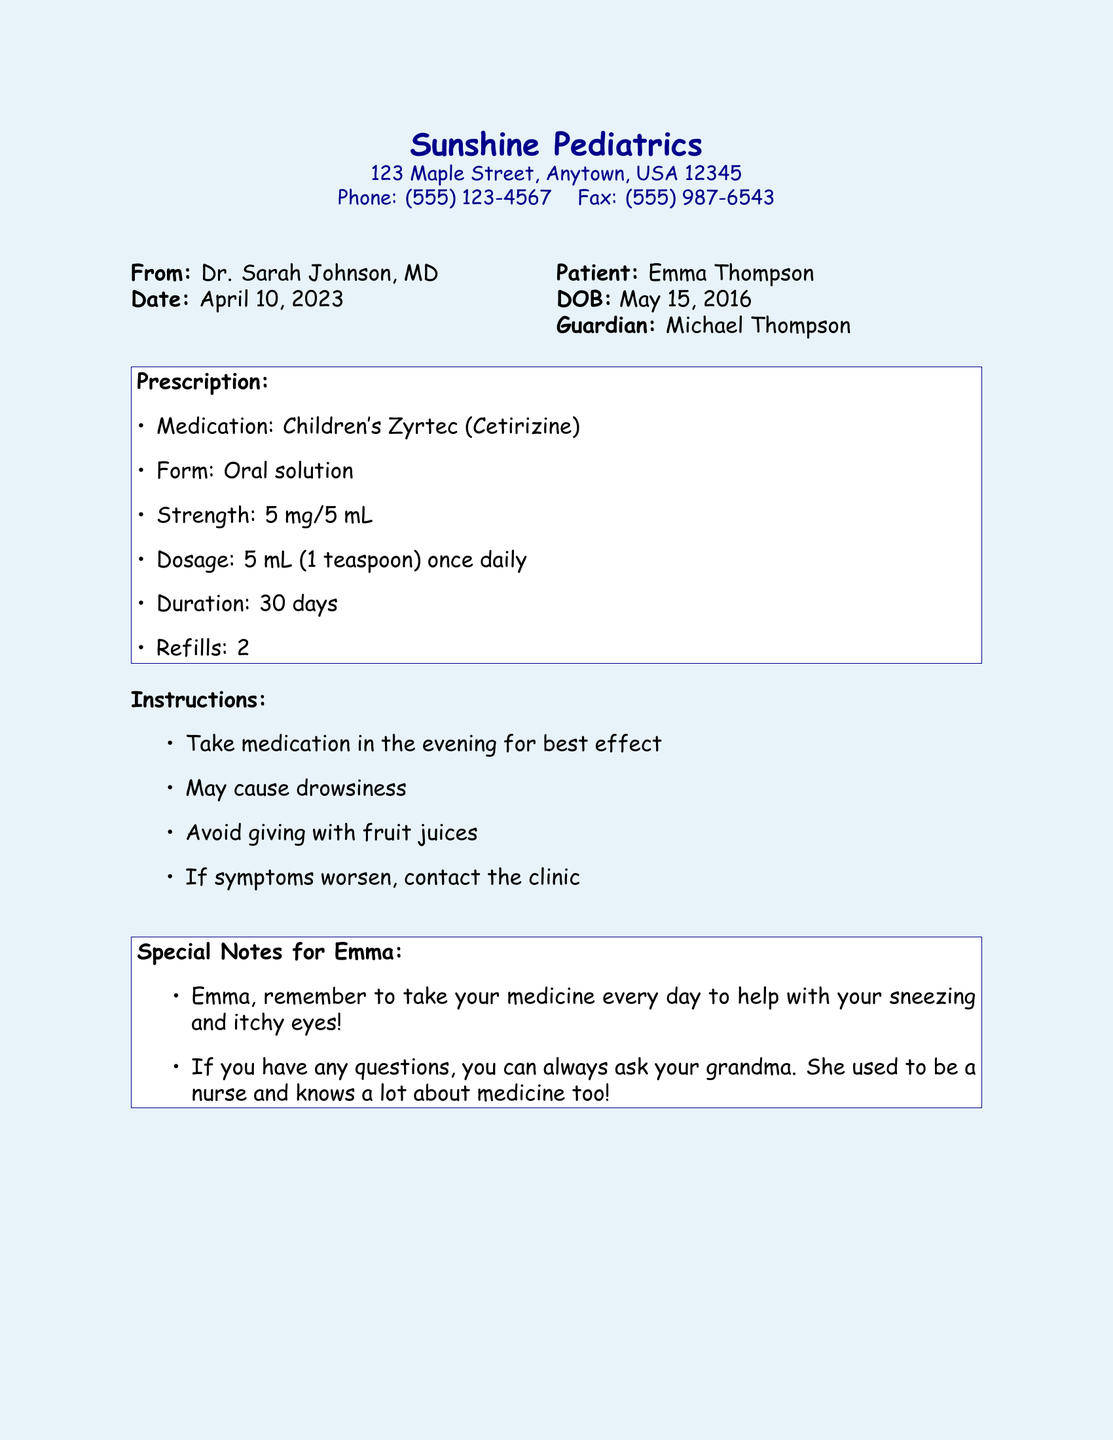What is the name of the patient? The patient's name is mentioned in the document as Emma Thompson.
Answer: Emma Thompson What is the name of the medication prescribed? The document specifies the medication as Children's Zyrtec.
Answer: Children's Zyrtec What is the dosage form of the medication? The document states the dosage form of the medication is an oral solution.
Answer: Oral solution How long should the medication be taken? The duration for taking the medication is specified as 30 days in the document.
Answer: 30 days When should the medication be taken? The document recommends taking the medication in the evening for best effect.
Answer: Evening What is the strength of the medication? The strength of the medication is noted as 5 mg/5 mL in the document.
Answer: 5 mg/5 mL How many refills are allowed? The number of refills mentioned in the document is 2.
Answer: 2 Who is the prescribing doctor? The doctor's name is provided in the document as Dr. Sarah Johnson.
Answer: Dr. Sarah Johnson What should be avoided when taking the medication? The document advises avoiding giving the medication with fruit juices.
Answer: Fruit juices 